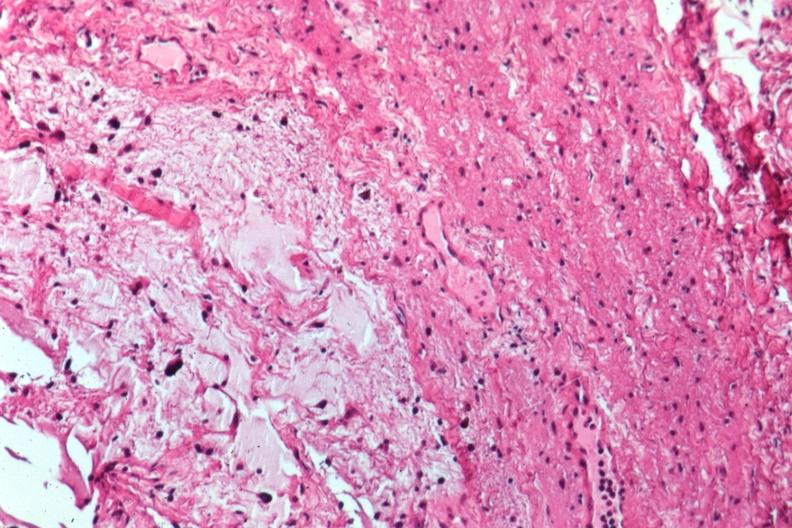s retroperitoneum present?
Answer the question using a single word or phrase. No 